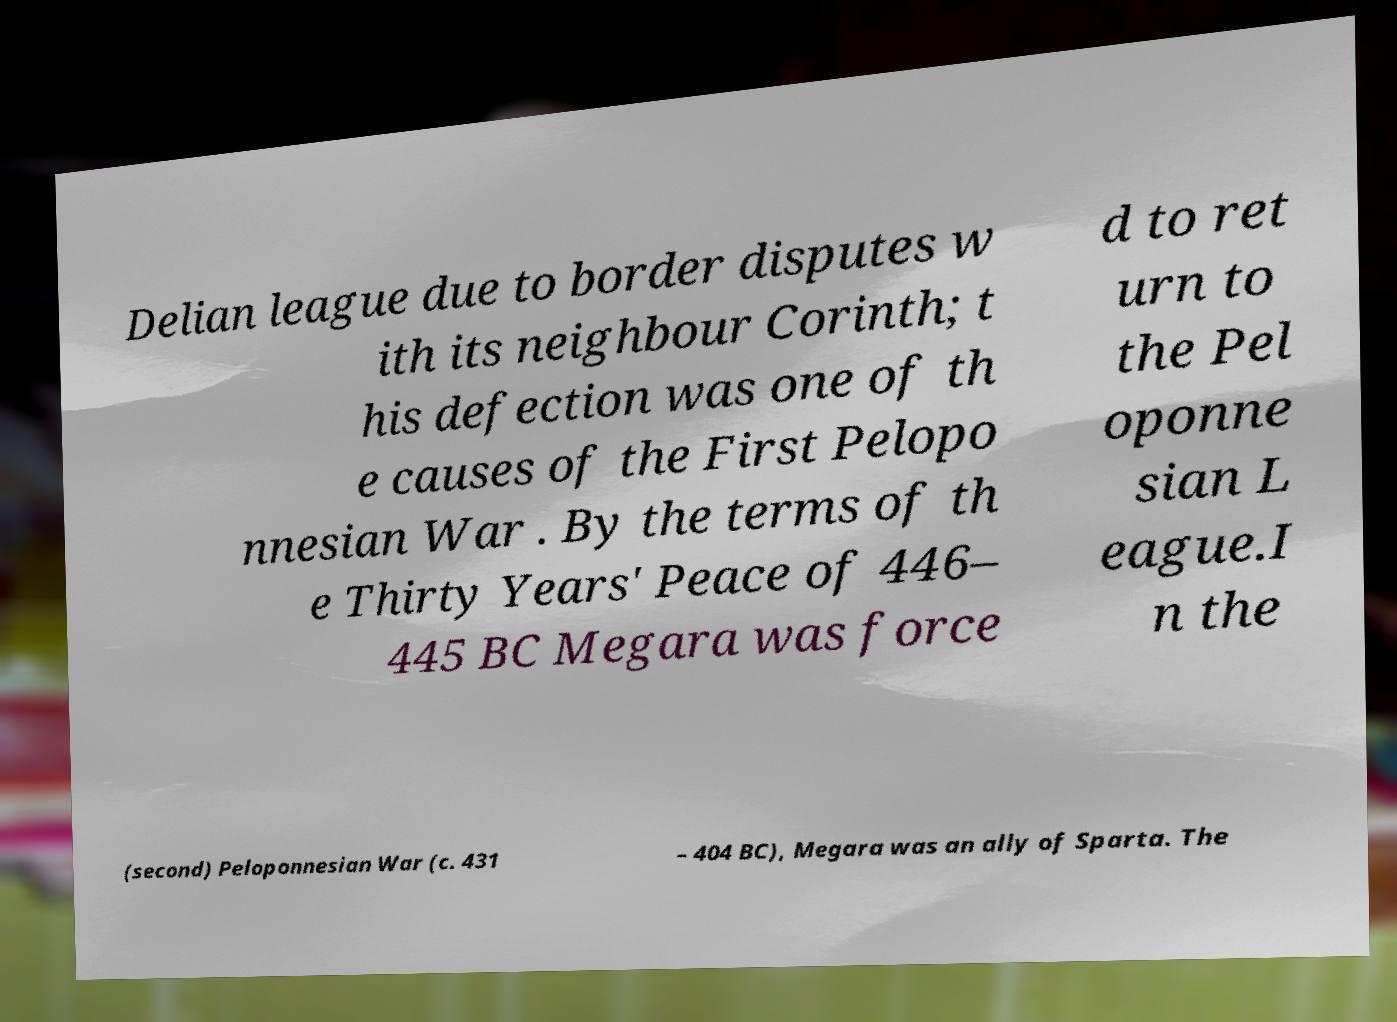For documentation purposes, I need the text within this image transcribed. Could you provide that? Delian league due to border disputes w ith its neighbour Corinth; t his defection was one of th e causes of the First Pelopo nnesian War . By the terms of th e Thirty Years' Peace of 446– 445 BC Megara was force d to ret urn to the Pel oponne sian L eague.I n the (second) Peloponnesian War (c. 431 – 404 BC), Megara was an ally of Sparta. The 